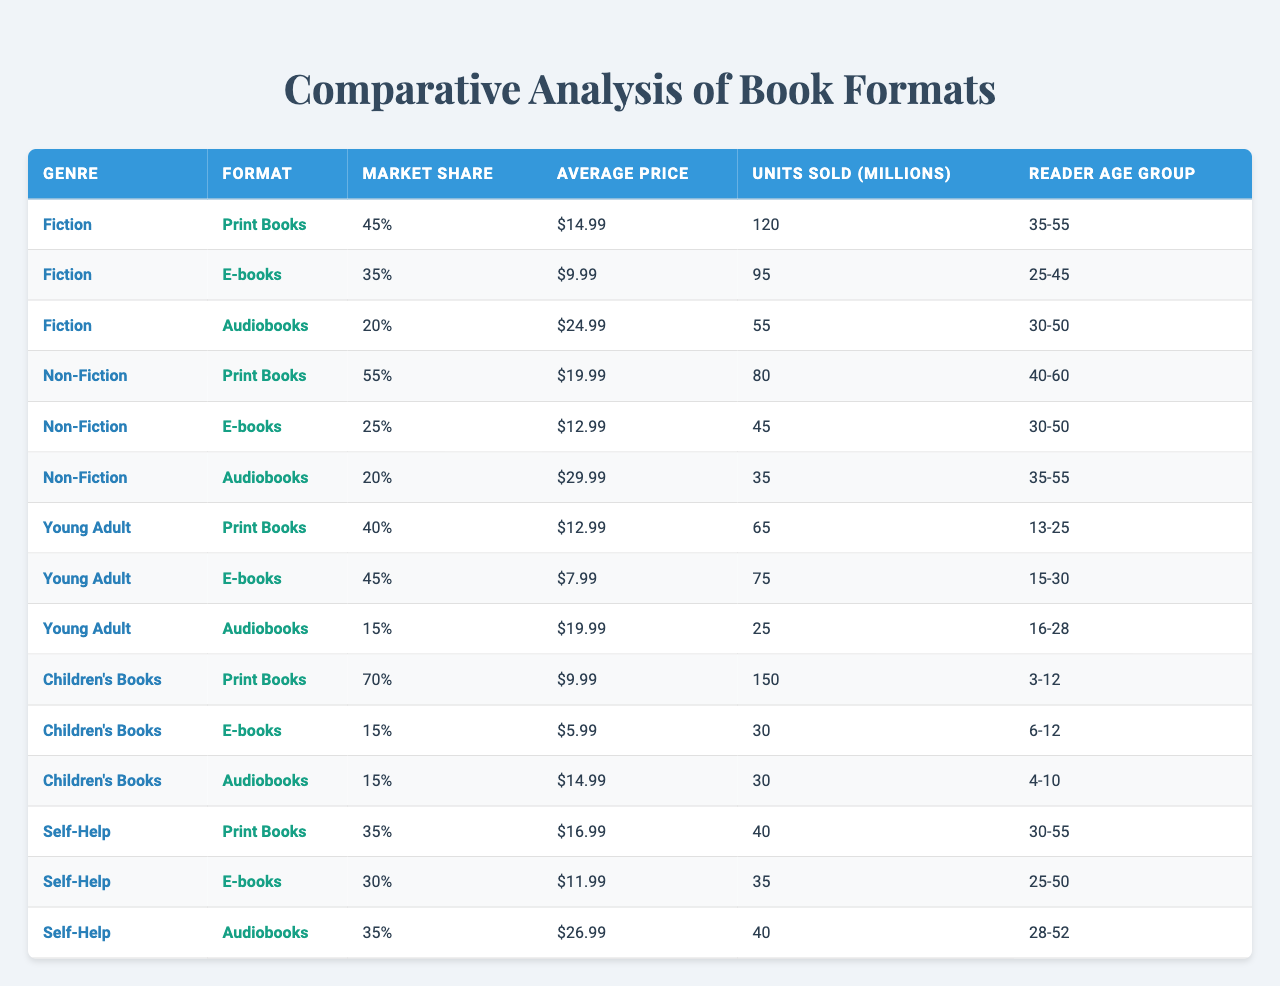What is the market share of print books in the Fiction genre? According to the table, the market share for print books in the Fiction genre is listed as 45%.
Answer: 45% What is the average price of e-books in the Non-Fiction genre? The table indicates that the average price for e-books in the Non-Fiction genre is $12.99.
Answer: $12.99 How many units of print books in Children's Books were sold? The table shows that 150 million units of print books in the Children's Books genre were sold.
Answer: 150 million Which genre has the highest market share for audiobooks? Comparing the market shares for audiobooks, Children's Books, Fiction, Non-Fiction, Young Adult, and Self-Help show that Non-Fiction has a market share of 20%, which is the highest among all genres.
Answer: Non-Fiction What percentage of units sold for e-books in Young Adult is greater than those sold in Self-Help? E-book units sold for Young Adult is 75 million and for Self-Help it is 35 million. The difference is 75 - 35 = 40 million, confirming Young Adult's e-book sales exceed Self-Help.
Answer: Yes How many total units sold for print books across all genres? The total units sold for print books can be calculated as: Fiction (120) + Non-Fiction (80) + Young Adult (65) + Children's Books (150) + Self-Help (40) = 455 million units.
Answer: 455 million Which format has the highest average price in the Self-Help genre? In the Self-Help genre, comparing average prices: print ($16.99), e-books ($11.99), and audiobooks ($26.99), we see that audiobooks have the highest average price.
Answer: Audiobooks Are e-books the least popular format for Children's Books based on market share? The market share for Children's Books shows print books at 70%, e-books at 15%, and audiobooks at 15%. Since e-books have the lowest market share, the statement is true.
Answer: Yes What is the difference in units sold between Fiction print books and Young Adult e-books? The units sold for Fiction print books is 120 million and for Young Adult e-books is 75 million. The difference is 120 - 75 = 45 million units.
Answer: 45 million What is the average market share of audiobooks across all genres? The market shares of audiobooks for all genres are 20%, 20%, 15%, 15%, and 35%. The total is 20 + 20 + 15 + 15 + 35 = 105; dividing by the number of genres (5) gives 105 / 5 = 21%.
Answer: 21% Which book format has the most significant difference in market share from print books to e-books in the Fiction genre? In the Fiction genre, print books have a market share of 45% and e-books have 35%. The difference is 45 - 35 = 10%, indicating print books lead by that margin.
Answer: 10% 